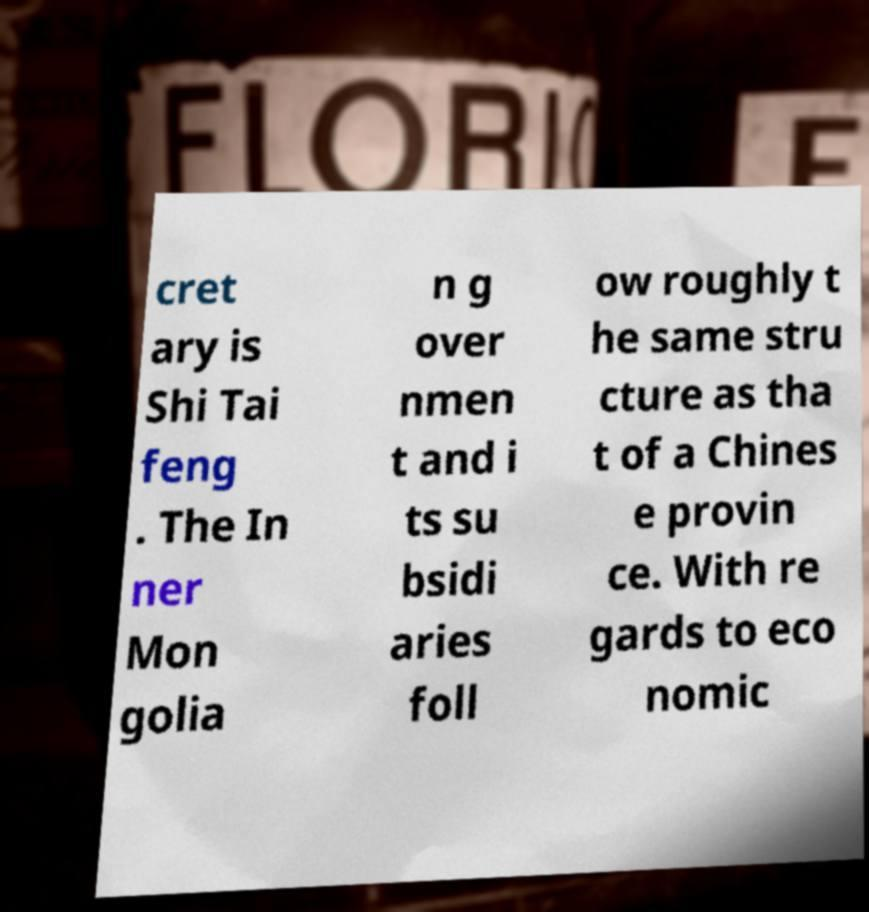Can you read and provide the text displayed in the image?This photo seems to have some interesting text. Can you extract and type it out for me? cret ary is Shi Tai feng . The In ner Mon golia n g over nmen t and i ts su bsidi aries foll ow roughly t he same stru cture as tha t of a Chines e provin ce. With re gards to eco nomic 